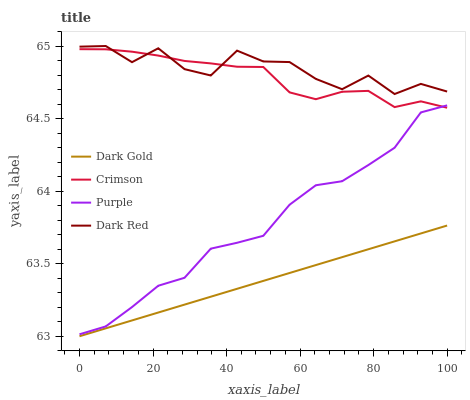Does Dark Gold have the minimum area under the curve?
Answer yes or no. Yes. Does Dark Red have the maximum area under the curve?
Answer yes or no. Yes. Does Purple have the minimum area under the curve?
Answer yes or no. No. Does Purple have the maximum area under the curve?
Answer yes or no. No. Is Dark Gold the smoothest?
Answer yes or no. Yes. Is Dark Red the roughest?
Answer yes or no. Yes. Is Purple the smoothest?
Answer yes or no. No. Is Purple the roughest?
Answer yes or no. No. Does Dark Gold have the lowest value?
Answer yes or no. Yes. Does Purple have the lowest value?
Answer yes or no. No. Does Dark Red have the highest value?
Answer yes or no. Yes. Does Purple have the highest value?
Answer yes or no. No. Is Dark Gold less than Dark Red?
Answer yes or no. Yes. Is Purple greater than Dark Gold?
Answer yes or no. Yes. Does Dark Red intersect Crimson?
Answer yes or no. Yes. Is Dark Red less than Crimson?
Answer yes or no. No. Is Dark Red greater than Crimson?
Answer yes or no. No. Does Dark Gold intersect Dark Red?
Answer yes or no. No. 